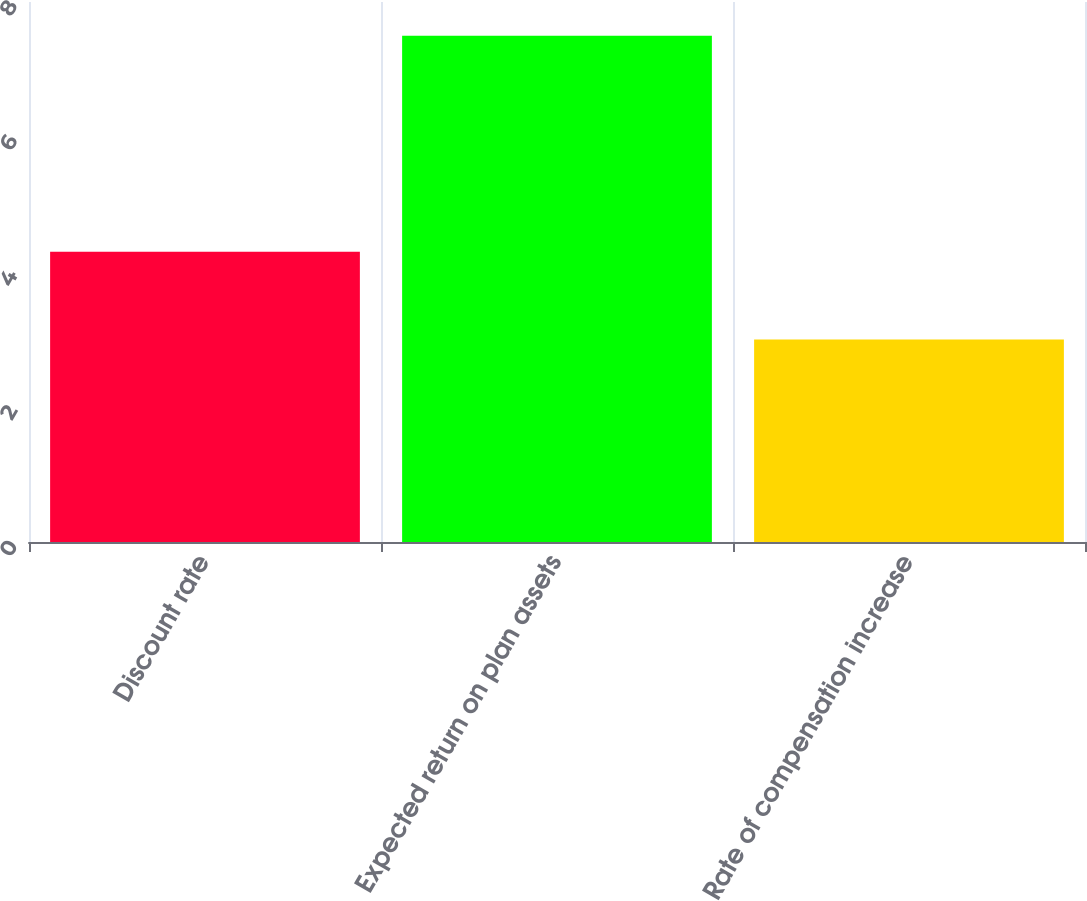<chart> <loc_0><loc_0><loc_500><loc_500><bar_chart><fcel>Discount rate<fcel>Expected return on plan assets<fcel>Rate of compensation increase<nl><fcel>4.3<fcel>7.5<fcel>3<nl></chart> 